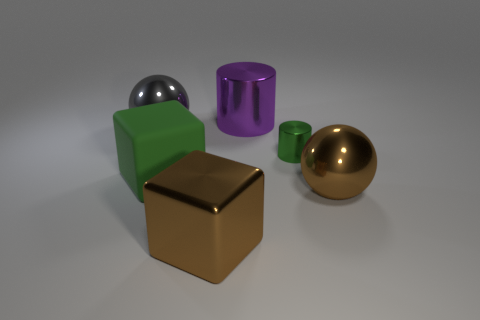Is the color of the large rubber thing the same as the small metallic cylinder?
Ensure brevity in your answer.  Yes. What is the material of the other object that is the same color as the matte object?
Your answer should be compact. Metal. There is a big thing behind the gray metal ball; what is it made of?
Ensure brevity in your answer.  Metal. Are the ball in front of the green matte object and the gray sphere made of the same material?
Give a very brief answer. Yes. How many things are either green cylinders or large objects that are behind the big brown metallic sphere?
Offer a very short reply. 4. What size is the other metallic object that is the same shape as the big gray object?
Provide a succinct answer. Large. Is there any other thing that is the same size as the metal block?
Give a very brief answer. Yes. There is a big gray sphere; are there any large purple shiny cylinders on the left side of it?
Offer a terse response. No. Does the large sphere on the left side of the green cube have the same color as the metal block on the right side of the gray ball?
Your answer should be very brief. No. Are there any tiny yellow shiny things that have the same shape as the tiny green object?
Your response must be concise. No. 